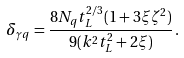Convert formula to latex. <formula><loc_0><loc_0><loc_500><loc_500>\delta _ { \gamma { q } } = \frac { 8 N _ { q } t _ { L } ^ { 2 / 3 } ( 1 + 3 \xi \zeta ^ { 2 } ) } { 9 ( k ^ { 2 } t _ { L } ^ { 2 } + 2 \xi ) } \, .</formula> 